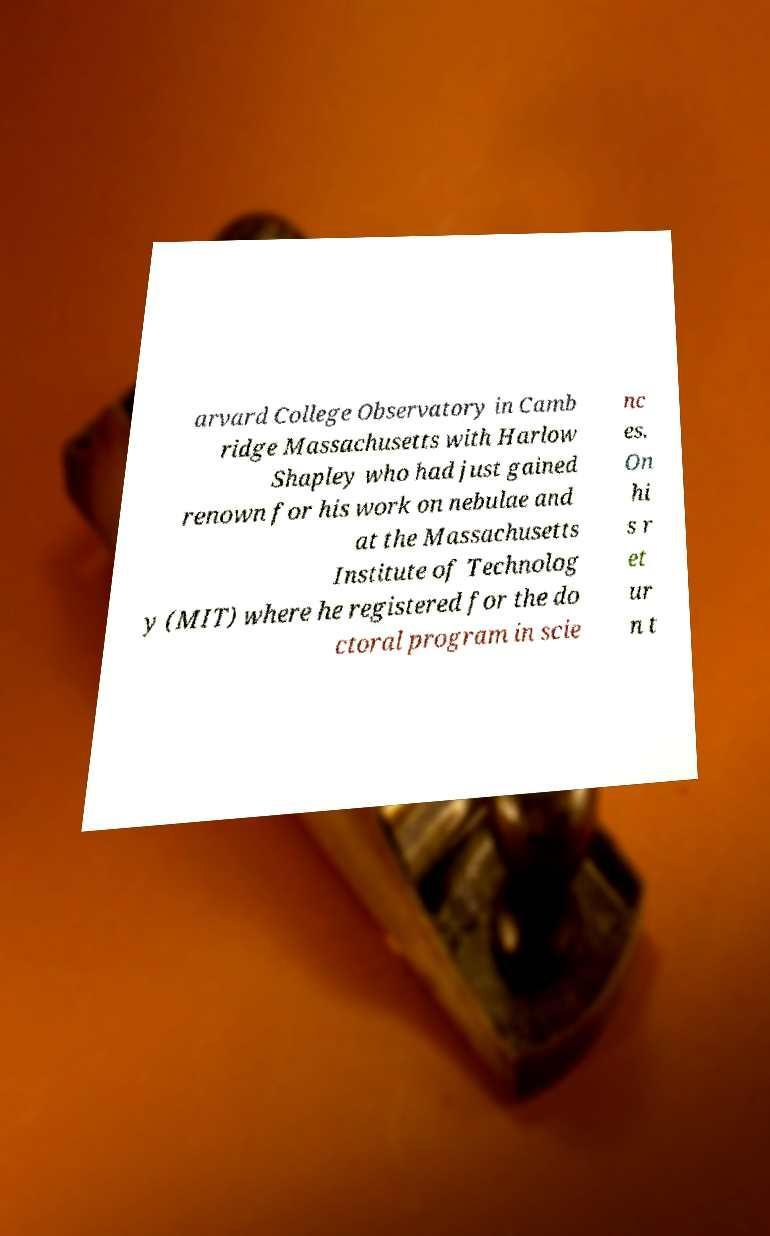Can you read and provide the text displayed in the image?This photo seems to have some interesting text. Can you extract and type it out for me? arvard College Observatory in Camb ridge Massachusetts with Harlow Shapley who had just gained renown for his work on nebulae and at the Massachusetts Institute of Technolog y (MIT) where he registered for the do ctoral program in scie nc es. On hi s r et ur n t 